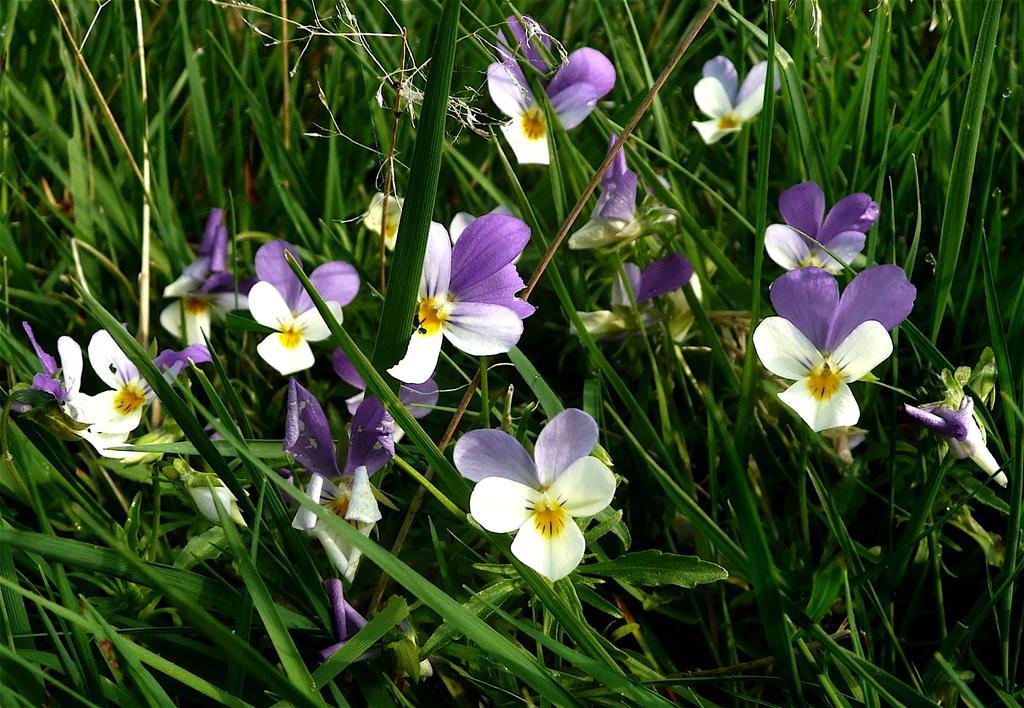What type of plants are in the image? There are flower plants in the image. What colors are the flowers on the plants? The flowers are white and purple in color. What type of notebook is visible in the image? There is no notebook present in the image. What is the weight of the flowers in the image? The weight of the flowers cannot be determined from the image, as it does not provide any information about their size or mass. 